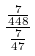Convert formula to latex. <formula><loc_0><loc_0><loc_500><loc_500>\frac { \frac { 7 } { 4 4 8 } } { \frac { 7 } { 4 7 } }</formula> 